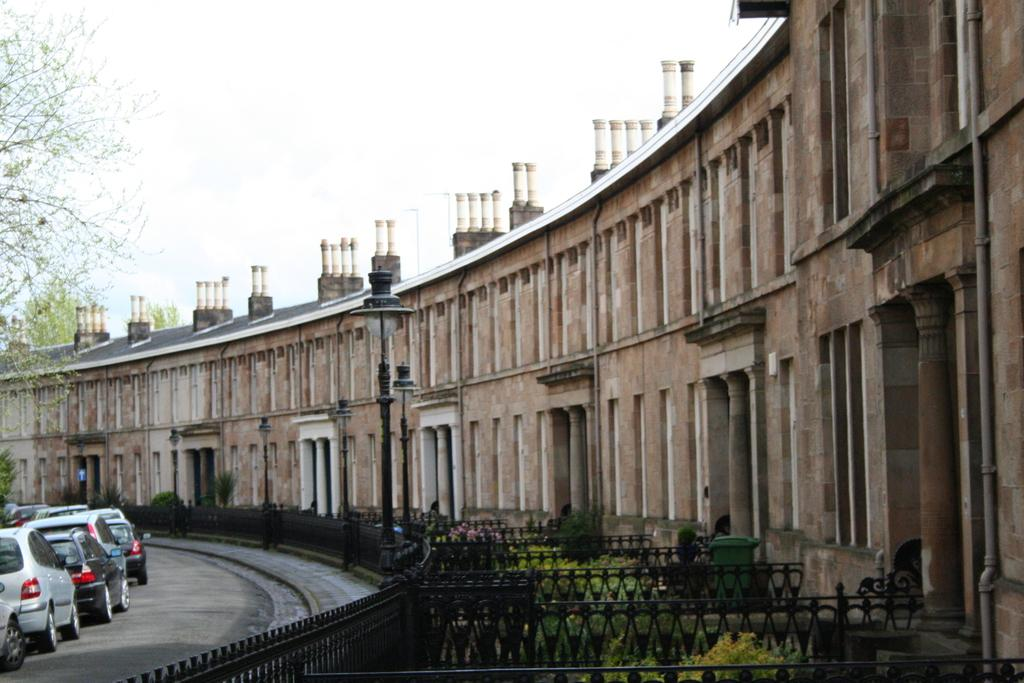What type of structures can be seen in the image? There are buildings in the image. What are the light poles used for in the image? The light poles provide illumination in the image. What might be used for safety or support in the image? There is railing in the image for safety or support. What type of vegetation is present in the image? There are plants and trees in the image. What might be used for ventilation or decoration in the image? There are grilles in the image for ventilation or decoration. What type of transportation is visible in the image? There are vehicles in the image. Where can the waste be seen in the image? There is no waste present in the image. What type of canvas is visible in the image? There is no canvas present in the image. 